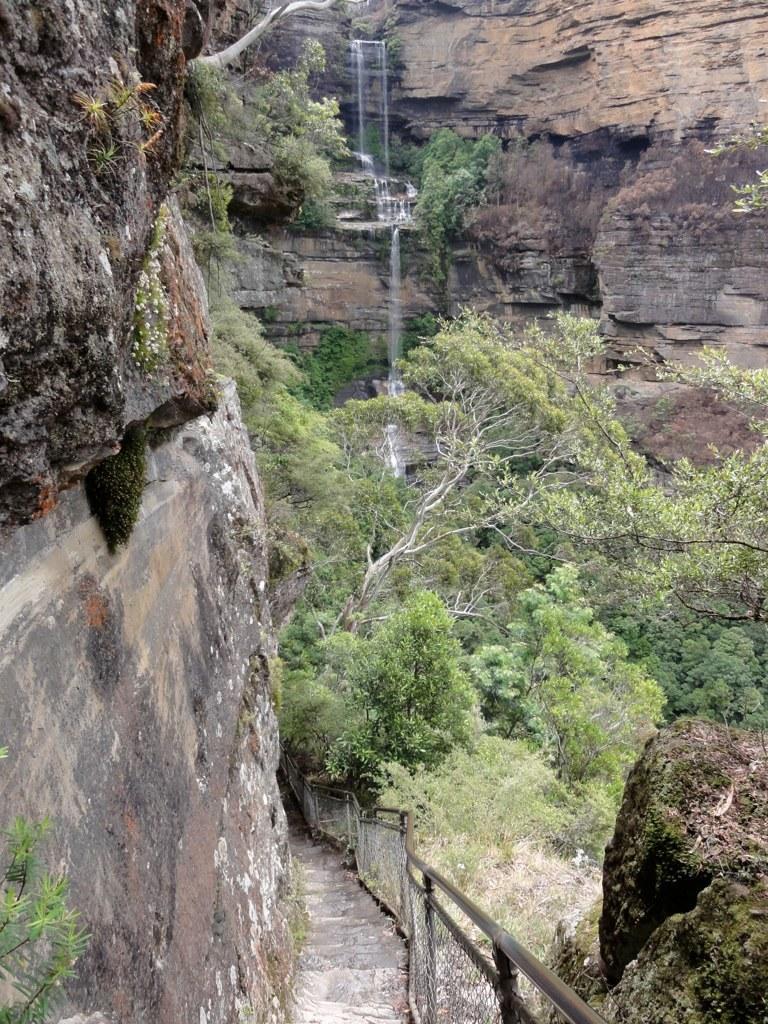Describe this image in one or two sentences. In this image, I can see a waterfall from the hills and the trees. At the bottom image, I can see the pathway and fence. 